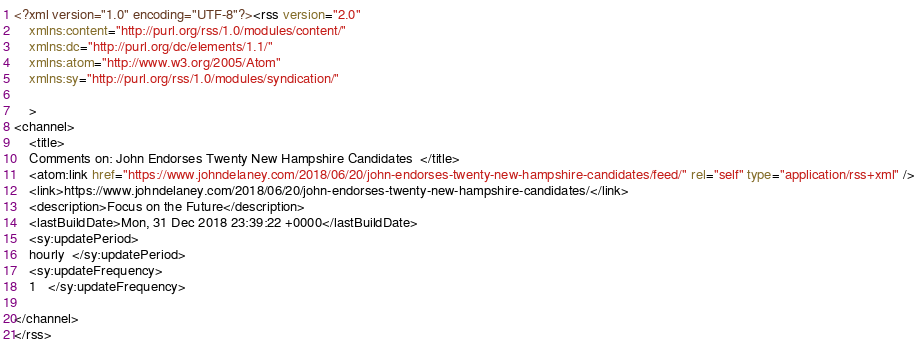Convert code to text. <code><loc_0><loc_0><loc_500><loc_500><_HTML_><?xml version="1.0" encoding="UTF-8"?><rss version="2.0"
	xmlns:content="http://purl.org/rss/1.0/modules/content/"
	xmlns:dc="http://purl.org/dc/elements/1.1/"
	xmlns:atom="http://www.w3.org/2005/Atom"
	xmlns:sy="http://purl.org/rss/1.0/modules/syndication/"
	
	>
<channel>
	<title>
	Comments on: John Endorses Twenty New Hampshire Candidates	</title>
	<atom:link href="https://www.johndelaney.com/2018/06/20/john-endorses-twenty-new-hampshire-candidates/feed/" rel="self" type="application/rss+xml" />
	<link>https://www.johndelaney.com/2018/06/20/john-endorses-twenty-new-hampshire-candidates/</link>
	<description>Focus on the Future</description>
	<lastBuildDate>Mon, 31 Dec 2018 23:39:22 +0000</lastBuildDate>
	<sy:updatePeriod>
	hourly	</sy:updatePeriod>
	<sy:updateFrequency>
	1	</sy:updateFrequency>
	
</channel>
</rss>
</code> 